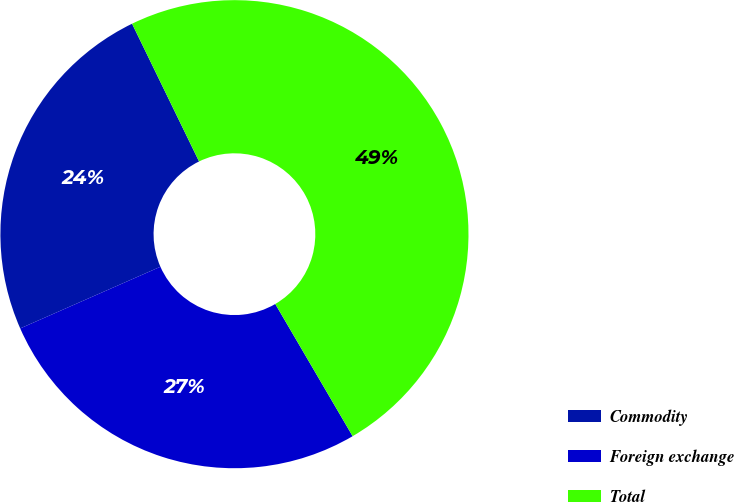Convert chart to OTSL. <chart><loc_0><loc_0><loc_500><loc_500><pie_chart><fcel>Commodity<fcel>Foreign exchange<fcel>Total<nl><fcel>24.39%<fcel>26.83%<fcel>48.78%<nl></chart> 